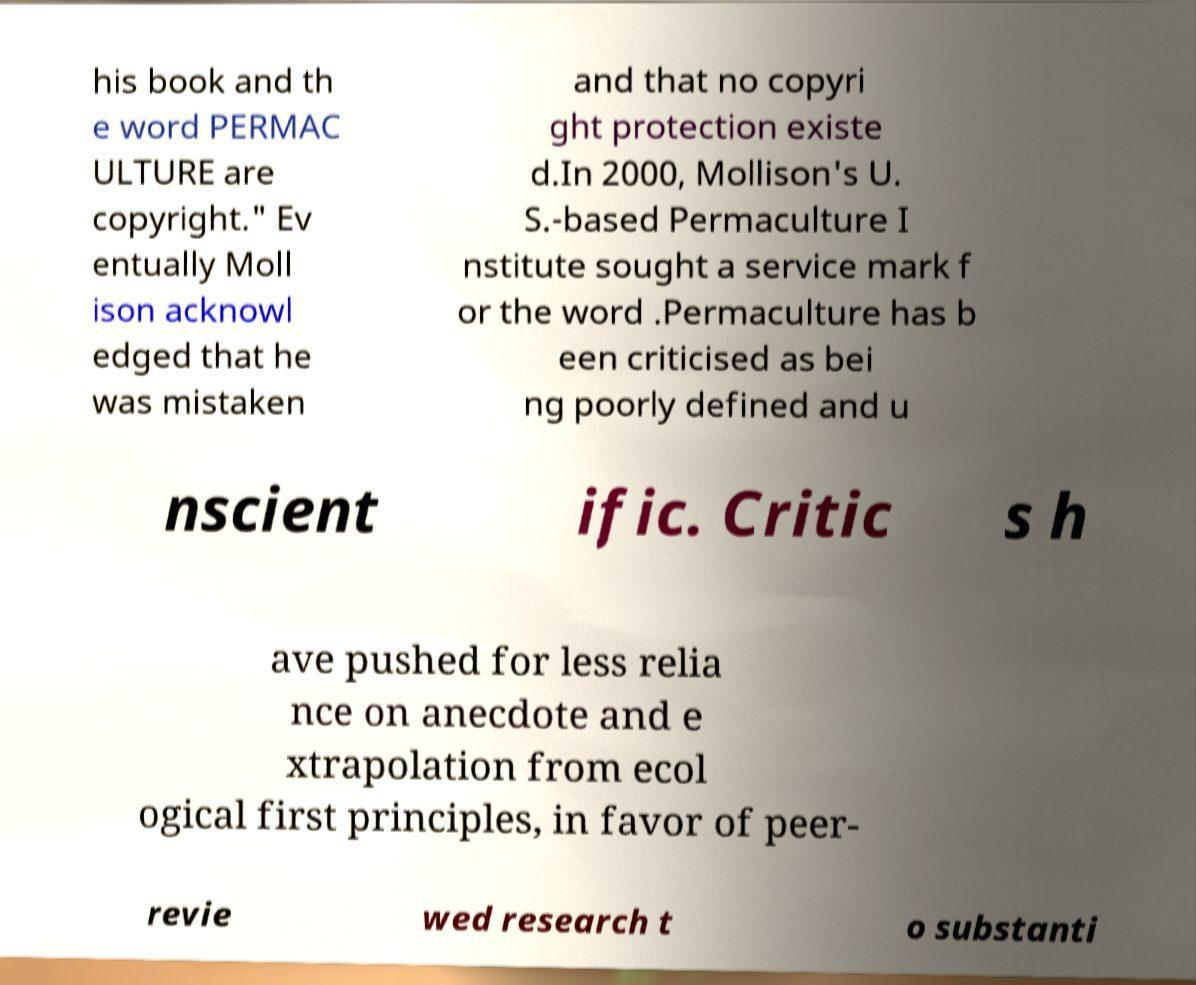Can you read and provide the text displayed in the image?This photo seems to have some interesting text. Can you extract and type it out for me? his book and th e word PERMAC ULTURE are copyright." Ev entually Moll ison acknowl edged that he was mistaken and that no copyri ght protection existe d.In 2000, Mollison's U. S.-based Permaculture I nstitute sought a service mark f or the word .Permaculture has b een criticised as bei ng poorly defined and u nscient ific. Critic s h ave pushed for less relia nce on anecdote and e xtrapolation from ecol ogical first principles, in favor of peer- revie wed research t o substanti 